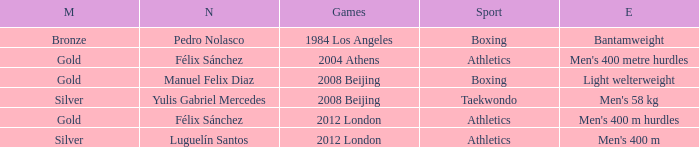Which Medal had a Name of félix sánchez, and a Games of 2012 london? Gold. 